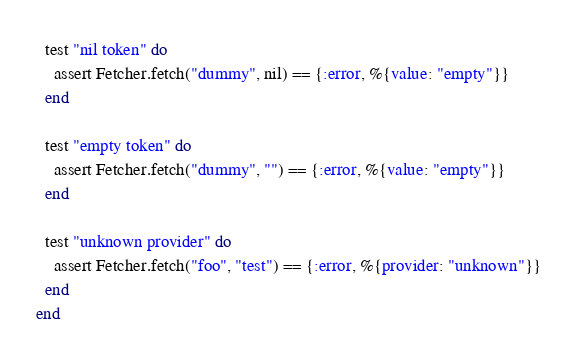Convert code to text. <code><loc_0><loc_0><loc_500><loc_500><_Elixir_>  test "nil token" do
    assert Fetcher.fetch("dummy", nil) == {:error, %{value: "empty"}}
  end

  test "empty token" do
    assert Fetcher.fetch("dummy", "") == {:error, %{value: "empty"}}
  end

  test "unknown provider" do
    assert Fetcher.fetch("foo", "test") == {:error, %{provider: "unknown"}}
  end
end
</code> 